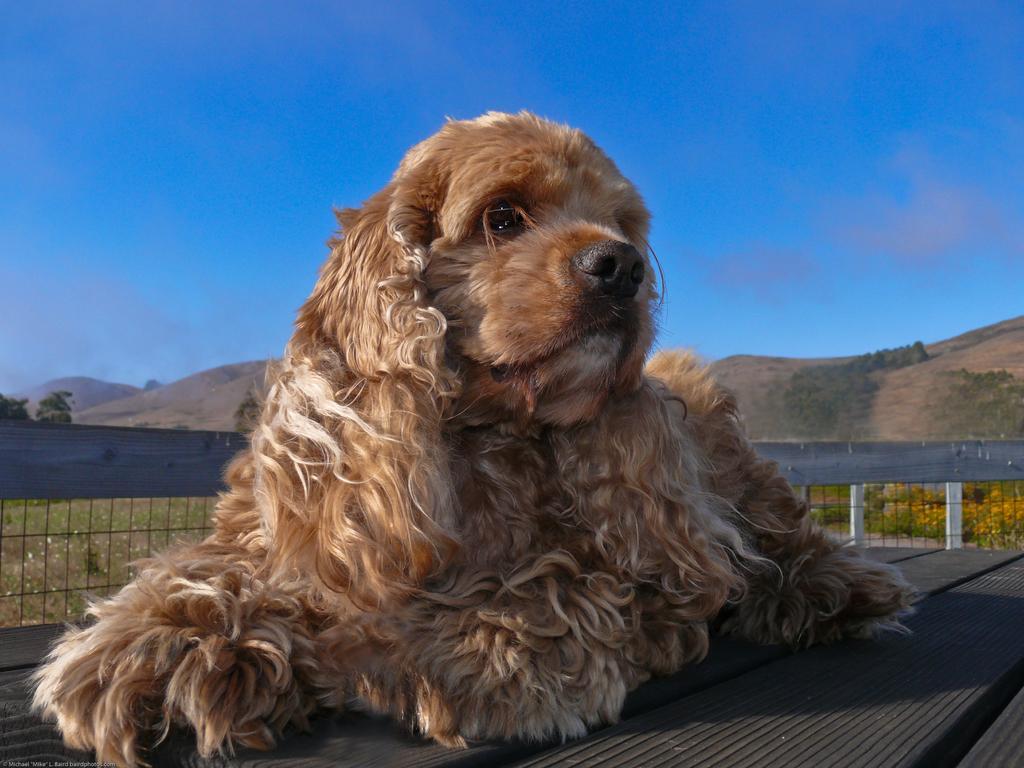In one or two sentences, can you explain what this image depicts? In this image we can see a dog on the wooden surface, there is a fencing, plants, flowers, trees, mountains, also we can see the sky. 